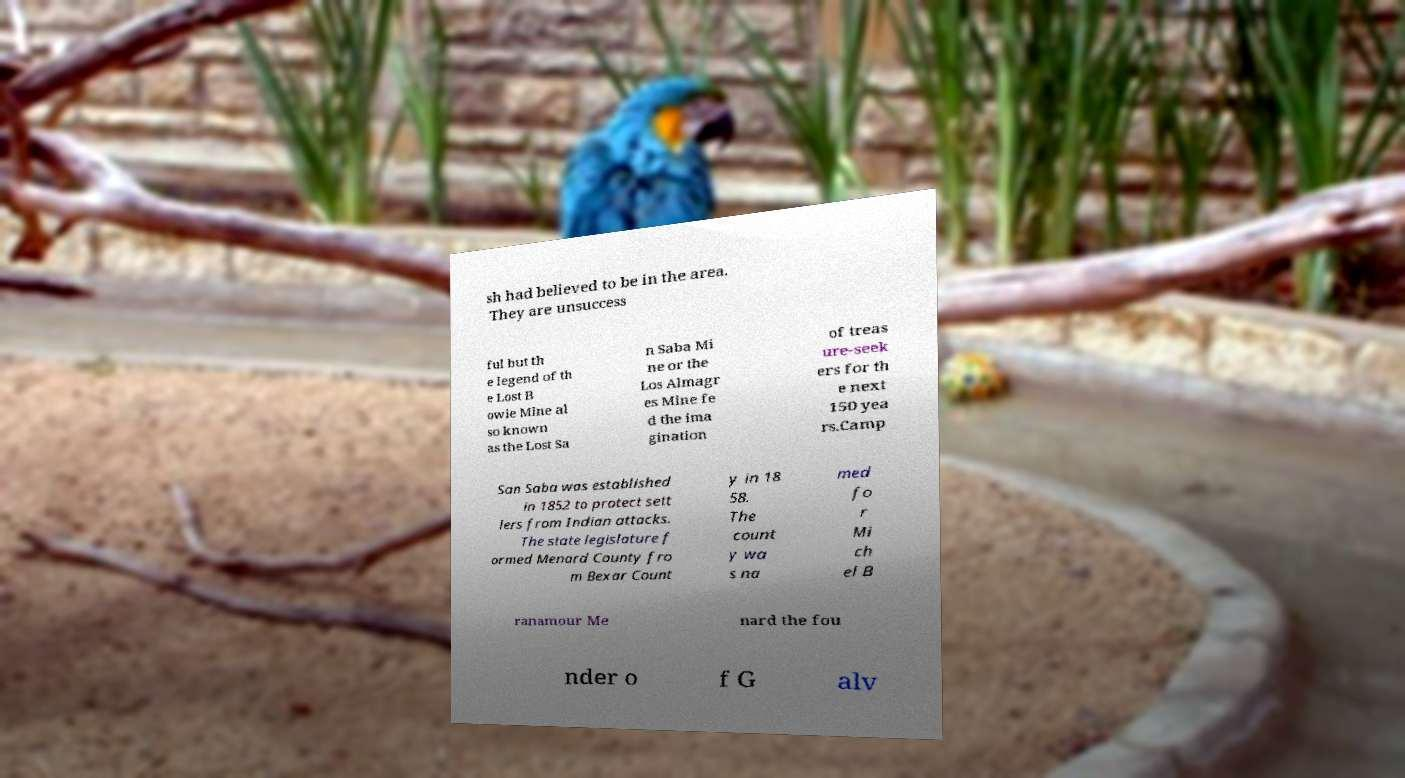Could you assist in decoding the text presented in this image and type it out clearly? sh had believed to be in the area. They are unsuccess ful but th e legend of th e Lost B owie Mine al so known as the Lost Sa n Saba Mi ne or the Los Almagr es Mine fe d the ima gination of treas ure-seek ers for th e next 150 yea rs.Camp San Saba was established in 1852 to protect sett lers from Indian attacks. The state legislature f ormed Menard County fro m Bexar Count y in 18 58. The count y wa s na med fo r Mi ch el B ranamour Me nard the fou nder o f G alv 